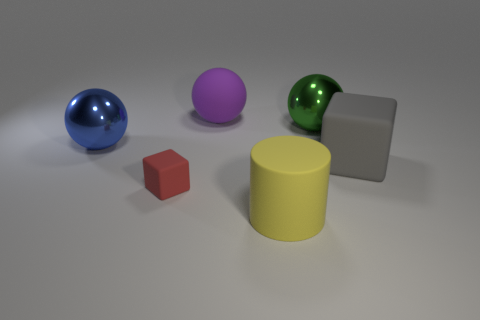Subtract all green metal spheres. How many spheres are left? 2 Subtract 1 balls. How many balls are left? 2 Add 3 big green shiny objects. How many objects exist? 9 Subtract all cylinders. How many objects are left? 5 Add 4 small matte objects. How many small matte objects are left? 5 Add 4 large rubber blocks. How many large rubber blocks exist? 5 Subtract 0 purple cylinders. How many objects are left? 6 Subtract all tiny purple rubber cylinders. Subtract all spheres. How many objects are left? 3 